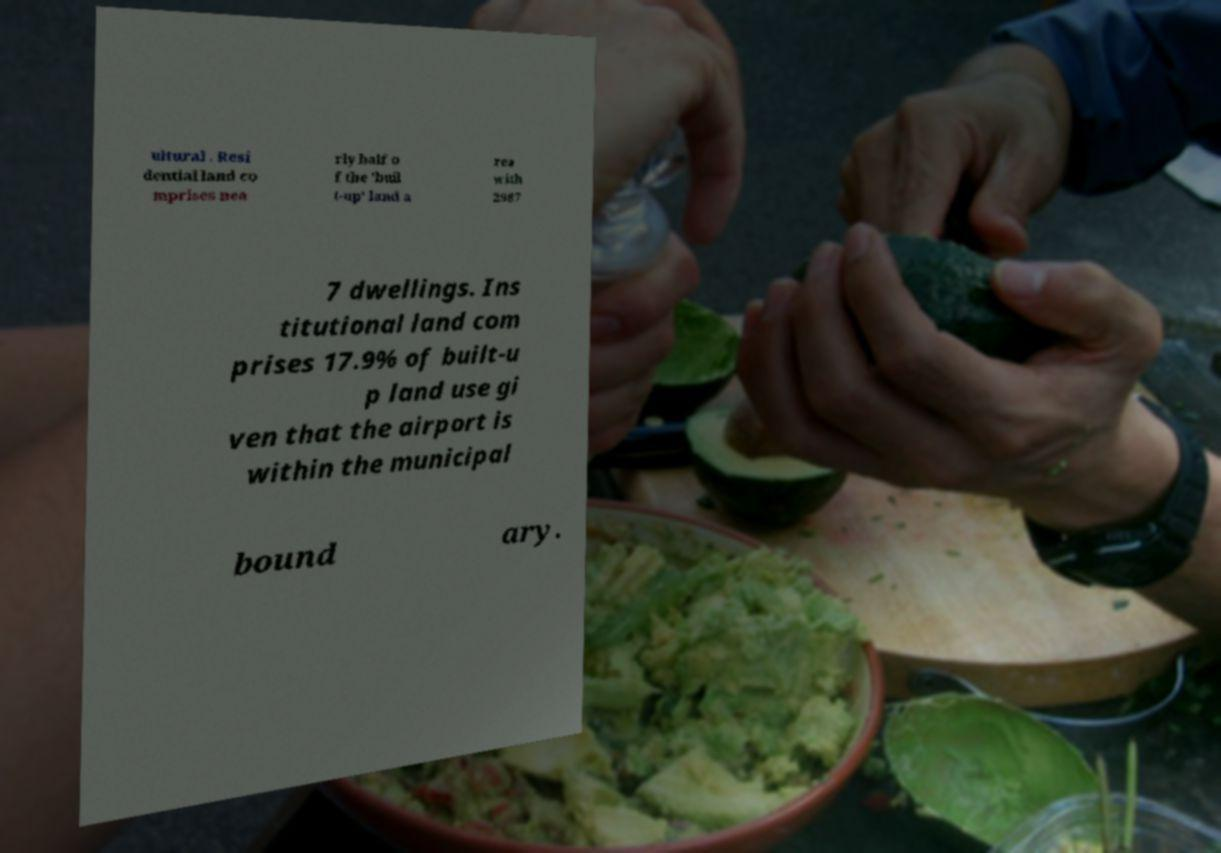Could you extract and type out the text from this image? ultural . Resi dential land co mprises nea rly half o f the 'buil t-up' land a rea with 2987 7 dwellings. Ins titutional land com prises 17.9% of built-u p land use gi ven that the airport is within the municipal bound ary. 